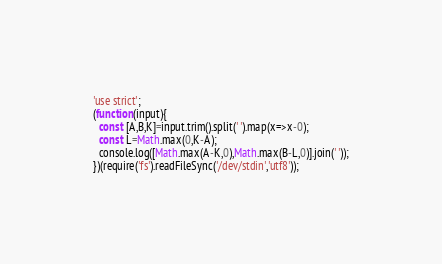Convert code to text. <code><loc_0><loc_0><loc_500><loc_500><_JavaScript_>'use strict';
(function(input){
  const [A,B,K]=input.trim().split(' ').map(x=>x-0);
  const L=Math.max(0,K-A);
  console.log([Math.max(A-K,0),Math.max(B-L,0)].join(' '));
})(require('fs').readFileSync('/dev/stdin','utf8'));</code> 